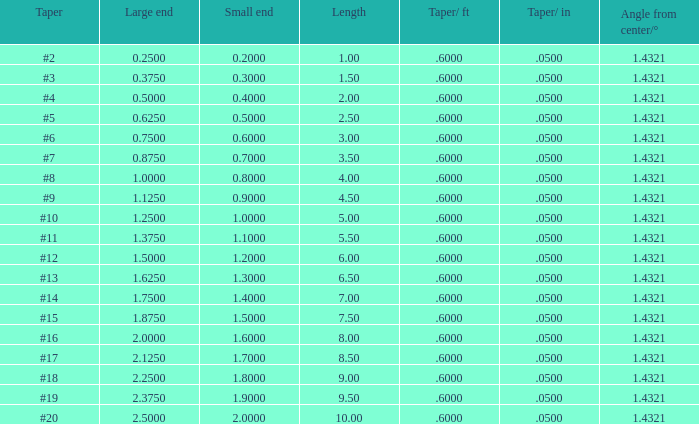Which taper/in that has a minor end greater than None. 